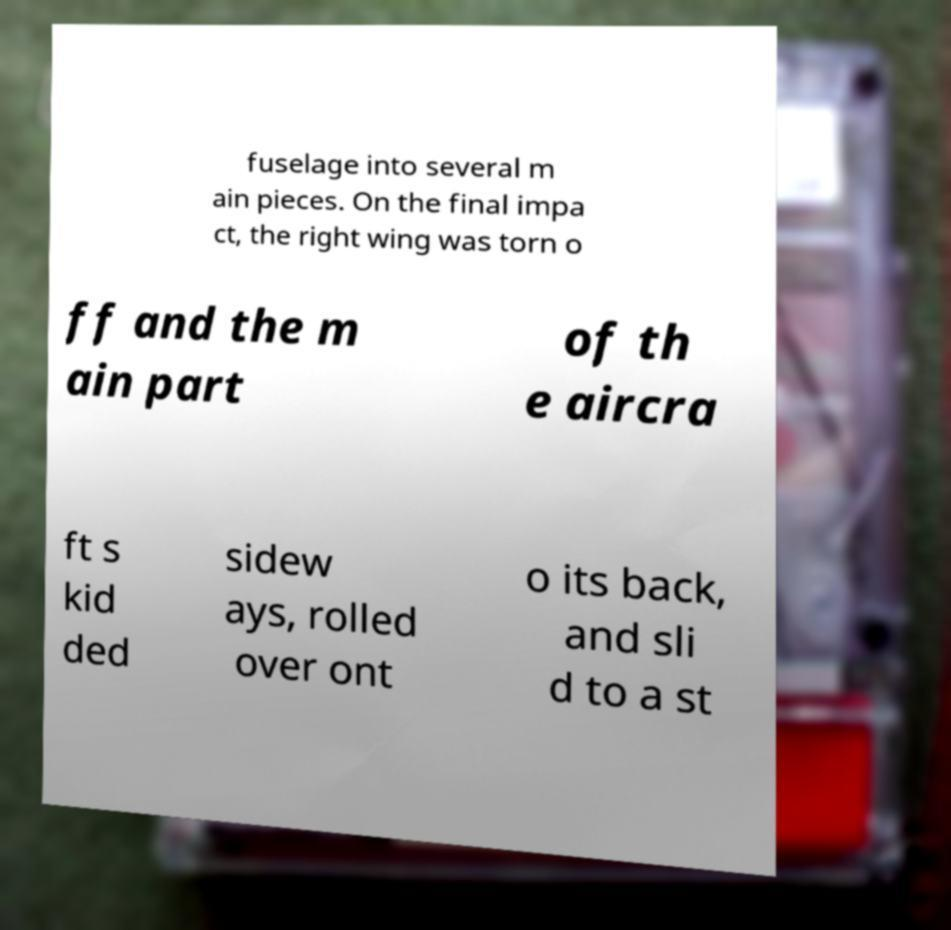Could you assist in decoding the text presented in this image and type it out clearly? fuselage into several m ain pieces. On the final impa ct, the right wing was torn o ff and the m ain part of th e aircra ft s kid ded sidew ays, rolled over ont o its back, and sli d to a st 